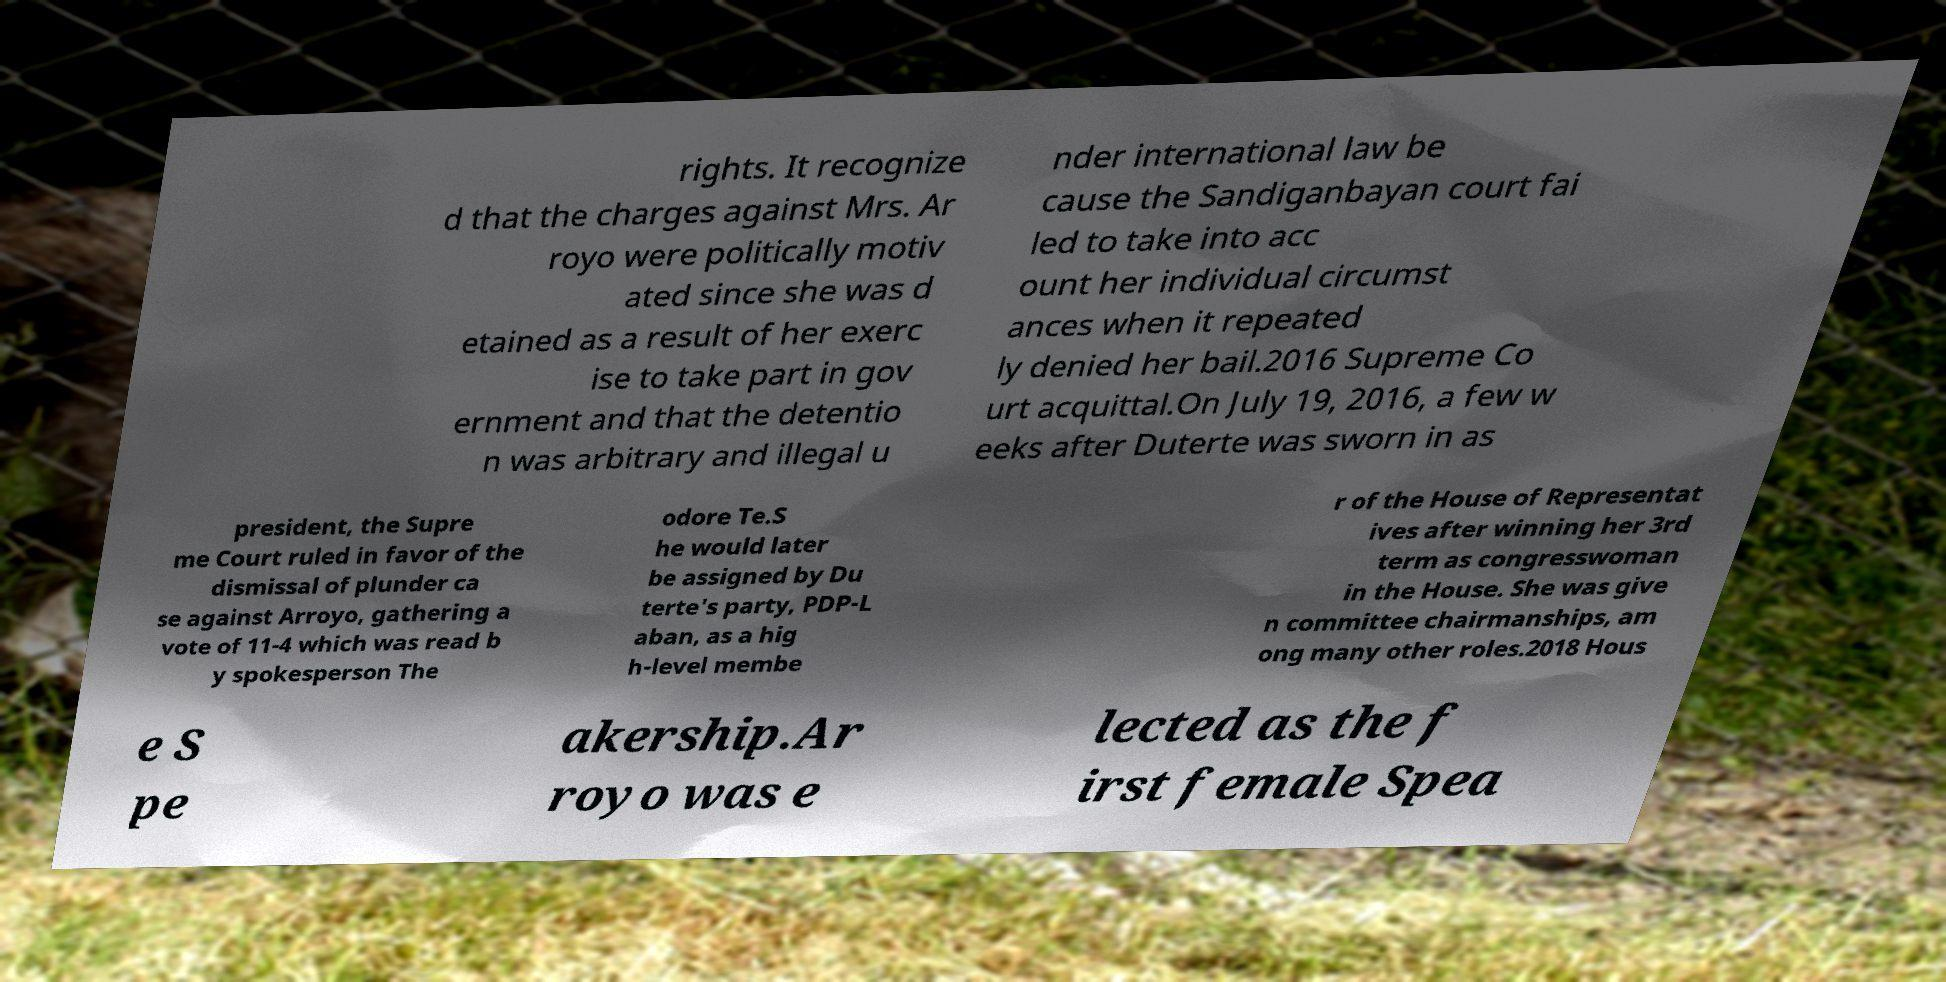Please read and relay the text visible in this image. What does it say? rights. It recognize d that the charges against Mrs. Ar royo were politically motiv ated since she was d etained as a result of her exerc ise to take part in gov ernment and that the detentio n was arbitrary and illegal u nder international law be cause the Sandiganbayan court fai led to take into acc ount her individual circumst ances when it repeated ly denied her bail.2016 Supreme Co urt acquittal.On July 19, 2016, a few w eeks after Duterte was sworn in as president, the Supre me Court ruled in favor of the dismissal of plunder ca se against Arroyo, gathering a vote of 11-4 which was read b y spokesperson The odore Te.S he would later be assigned by Du terte's party, PDP-L aban, as a hig h-level membe r of the House of Representat ives after winning her 3rd term as congresswoman in the House. She was give n committee chairmanships, am ong many other roles.2018 Hous e S pe akership.Ar royo was e lected as the f irst female Spea 